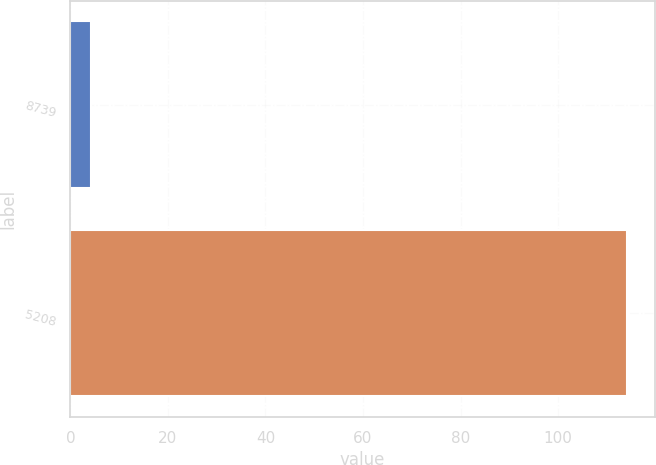Convert chart. <chart><loc_0><loc_0><loc_500><loc_500><bar_chart><fcel>8739<fcel>5208<nl><fcel>4.3<fcel>114.1<nl></chart> 